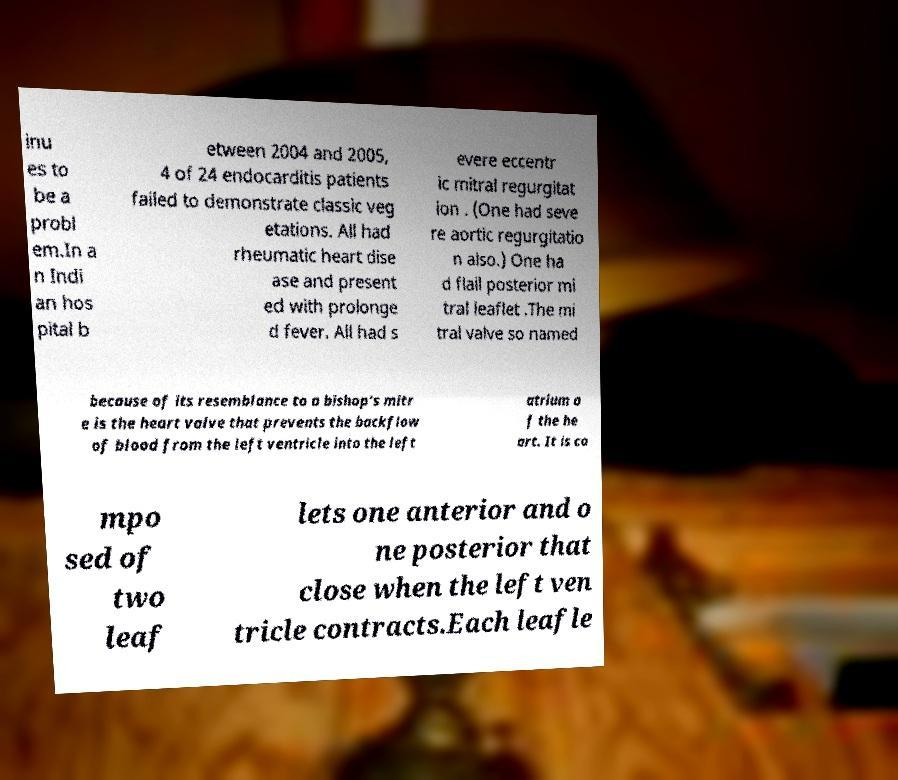Could you extract and type out the text from this image? inu es to be a probl em.In a n Indi an hos pital b etween 2004 and 2005, 4 of 24 endocarditis patients failed to demonstrate classic veg etations. All had rheumatic heart dise ase and present ed with prolonge d fever. All had s evere eccentr ic mitral regurgitat ion . (One had seve re aortic regurgitatio n also.) One ha d flail posterior mi tral leaflet .The mi tral valve so named because of its resemblance to a bishop's mitr e is the heart valve that prevents the backflow of blood from the left ventricle into the left atrium o f the he art. It is co mpo sed of two leaf lets one anterior and o ne posterior that close when the left ven tricle contracts.Each leafle 